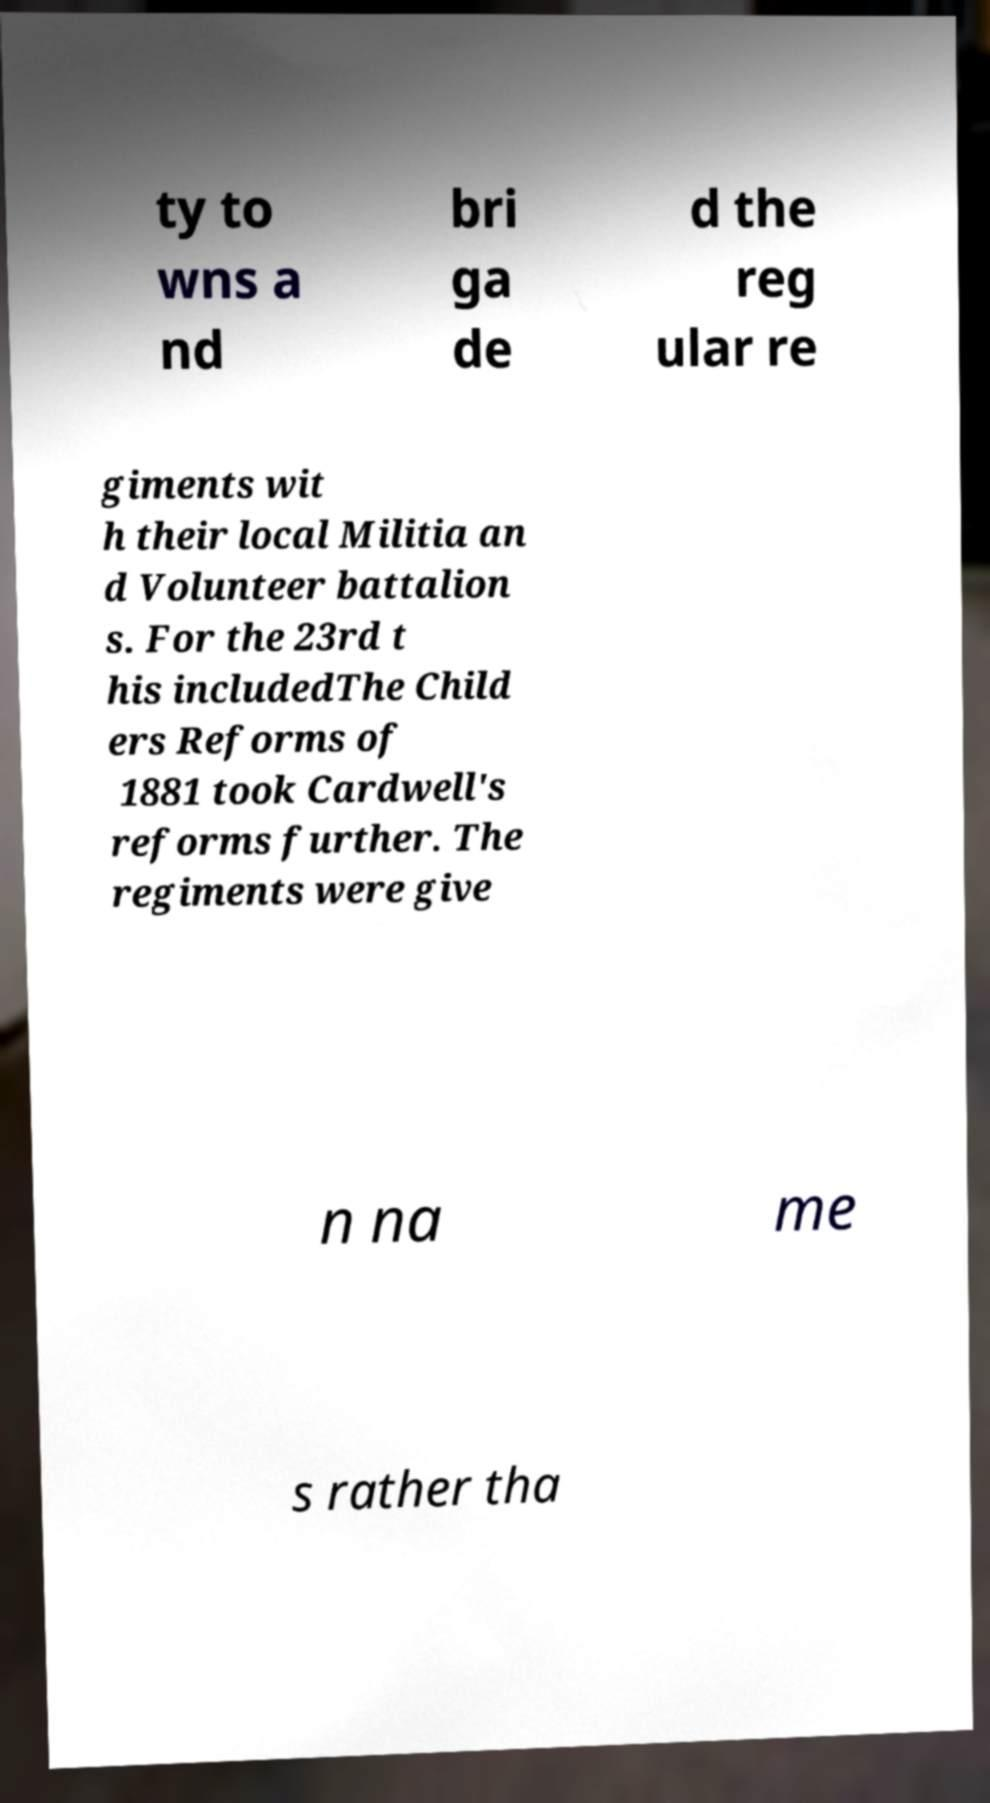Could you extract and type out the text from this image? ty to wns a nd bri ga de d the reg ular re giments wit h their local Militia an d Volunteer battalion s. For the 23rd t his includedThe Child ers Reforms of 1881 took Cardwell's reforms further. The regiments were give n na me s rather tha 